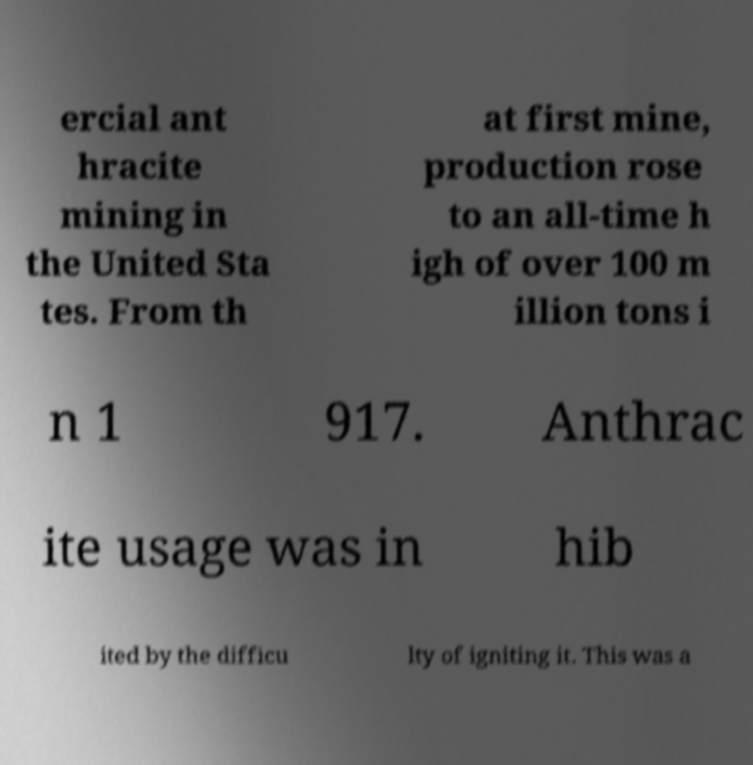Can you read and provide the text displayed in the image?This photo seems to have some interesting text. Can you extract and type it out for me? ercial ant hracite mining in the United Sta tes. From th at first mine, production rose to an all-time h igh of over 100 m illion tons i n 1 917. Anthrac ite usage was in hib ited by the difficu lty of igniting it. This was a 